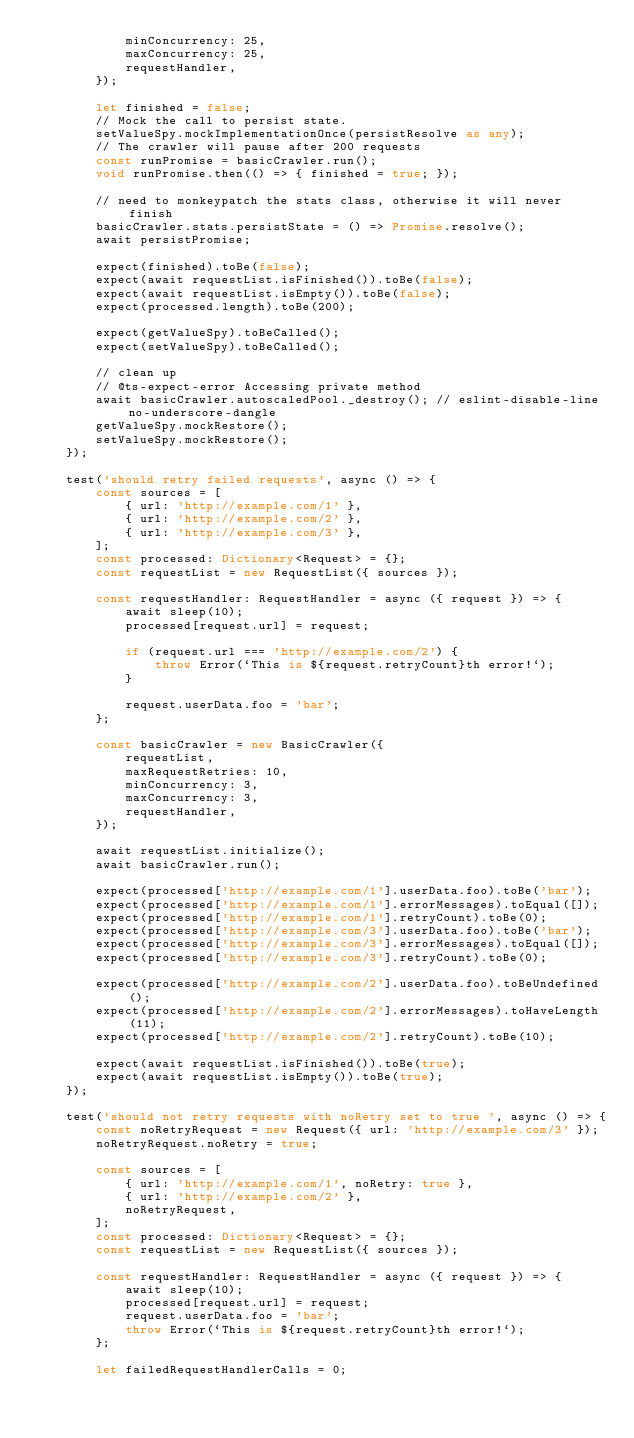Convert code to text. <code><loc_0><loc_0><loc_500><loc_500><_TypeScript_>            minConcurrency: 25,
            maxConcurrency: 25,
            requestHandler,
        });

        let finished = false;
        // Mock the call to persist state.
        setValueSpy.mockImplementationOnce(persistResolve as any);
        // The crawler will pause after 200 requests
        const runPromise = basicCrawler.run();
        void runPromise.then(() => { finished = true; });

        // need to monkeypatch the stats class, otherwise it will never finish
        basicCrawler.stats.persistState = () => Promise.resolve();
        await persistPromise;

        expect(finished).toBe(false);
        expect(await requestList.isFinished()).toBe(false);
        expect(await requestList.isEmpty()).toBe(false);
        expect(processed.length).toBe(200);

        expect(getValueSpy).toBeCalled();
        expect(setValueSpy).toBeCalled();

        // clean up
        // @ts-expect-error Accessing private method
        await basicCrawler.autoscaledPool._destroy(); // eslint-disable-line no-underscore-dangle
        getValueSpy.mockRestore();
        setValueSpy.mockRestore();
    });

    test('should retry failed requests', async () => {
        const sources = [
            { url: 'http://example.com/1' },
            { url: 'http://example.com/2' },
            { url: 'http://example.com/3' },
        ];
        const processed: Dictionary<Request> = {};
        const requestList = new RequestList({ sources });

        const requestHandler: RequestHandler = async ({ request }) => {
            await sleep(10);
            processed[request.url] = request;

            if (request.url === 'http://example.com/2') {
                throw Error(`This is ${request.retryCount}th error!`);
            }

            request.userData.foo = 'bar';
        };

        const basicCrawler = new BasicCrawler({
            requestList,
            maxRequestRetries: 10,
            minConcurrency: 3,
            maxConcurrency: 3,
            requestHandler,
        });

        await requestList.initialize();
        await basicCrawler.run();

        expect(processed['http://example.com/1'].userData.foo).toBe('bar');
        expect(processed['http://example.com/1'].errorMessages).toEqual([]);
        expect(processed['http://example.com/1'].retryCount).toBe(0);
        expect(processed['http://example.com/3'].userData.foo).toBe('bar');
        expect(processed['http://example.com/3'].errorMessages).toEqual([]);
        expect(processed['http://example.com/3'].retryCount).toBe(0);

        expect(processed['http://example.com/2'].userData.foo).toBeUndefined();
        expect(processed['http://example.com/2'].errorMessages).toHaveLength(11);
        expect(processed['http://example.com/2'].retryCount).toBe(10);

        expect(await requestList.isFinished()).toBe(true);
        expect(await requestList.isEmpty()).toBe(true);
    });

    test('should not retry requests with noRetry set to true ', async () => {
        const noRetryRequest = new Request({ url: 'http://example.com/3' });
        noRetryRequest.noRetry = true;

        const sources = [
            { url: 'http://example.com/1', noRetry: true },
            { url: 'http://example.com/2' },
            noRetryRequest,
        ];
        const processed: Dictionary<Request> = {};
        const requestList = new RequestList({ sources });

        const requestHandler: RequestHandler = async ({ request }) => {
            await sleep(10);
            processed[request.url] = request;
            request.userData.foo = 'bar';
            throw Error(`This is ${request.retryCount}th error!`);
        };

        let failedRequestHandlerCalls = 0;</code> 